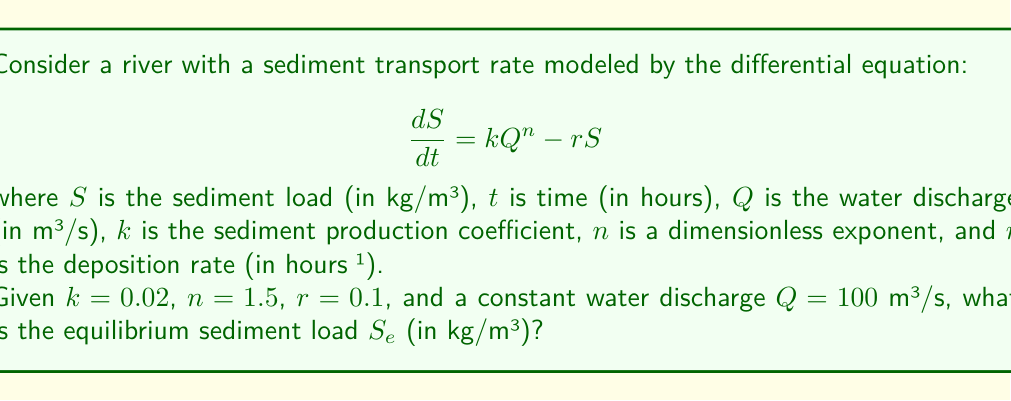Can you solve this math problem? To solve this problem, we need to follow these steps:

1) The equilibrium sediment load $S_e$ occurs when the rate of change of sediment load is zero, i.e., when $\frac{dS}{dt} = 0$.

2) Set the differential equation equal to zero:

   $$0 = kQ^n - rS_e$$

3) Substitute the given values:
   $k = 0.02$, $n = 1.5$, $r = 0.1$, $Q = 100$

   $$0 = 0.02 \cdot 100^{1.5} - 0.1S_e$$

4) Simplify:
   $$0 = 0.02 \cdot 1000 - 0.1S_e$$
   $$0 = 20 - 0.1S_e$$

5) Solve for $S_e$:
   $$0.1S_e = 20$$
   $$S_e = \frac{20}{0.1} = 200$$

Therefore, the equilibrium sediment load $S_e$ is 200 kg/m³.
Answer: 200 kg/m³ 